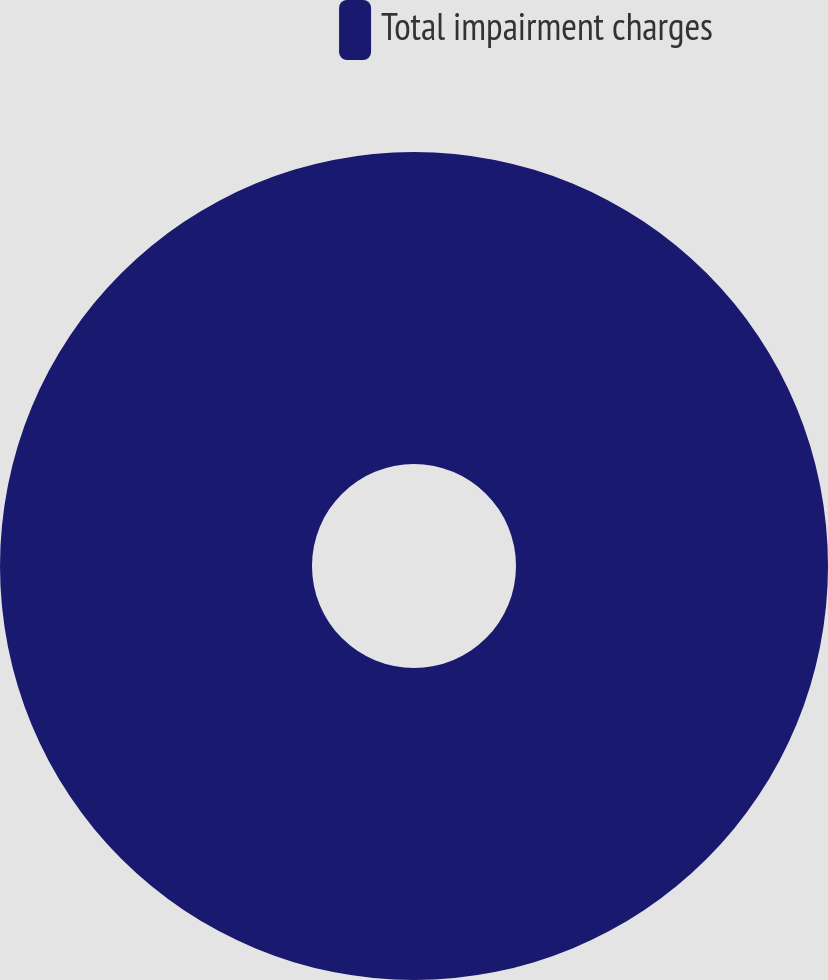Convert chart. <chart><loc_0><loc_0><loc_500><loc_500><pie_chart><fcel>Total impairment charges<nl><fcel>100.0%<nl></chart> 